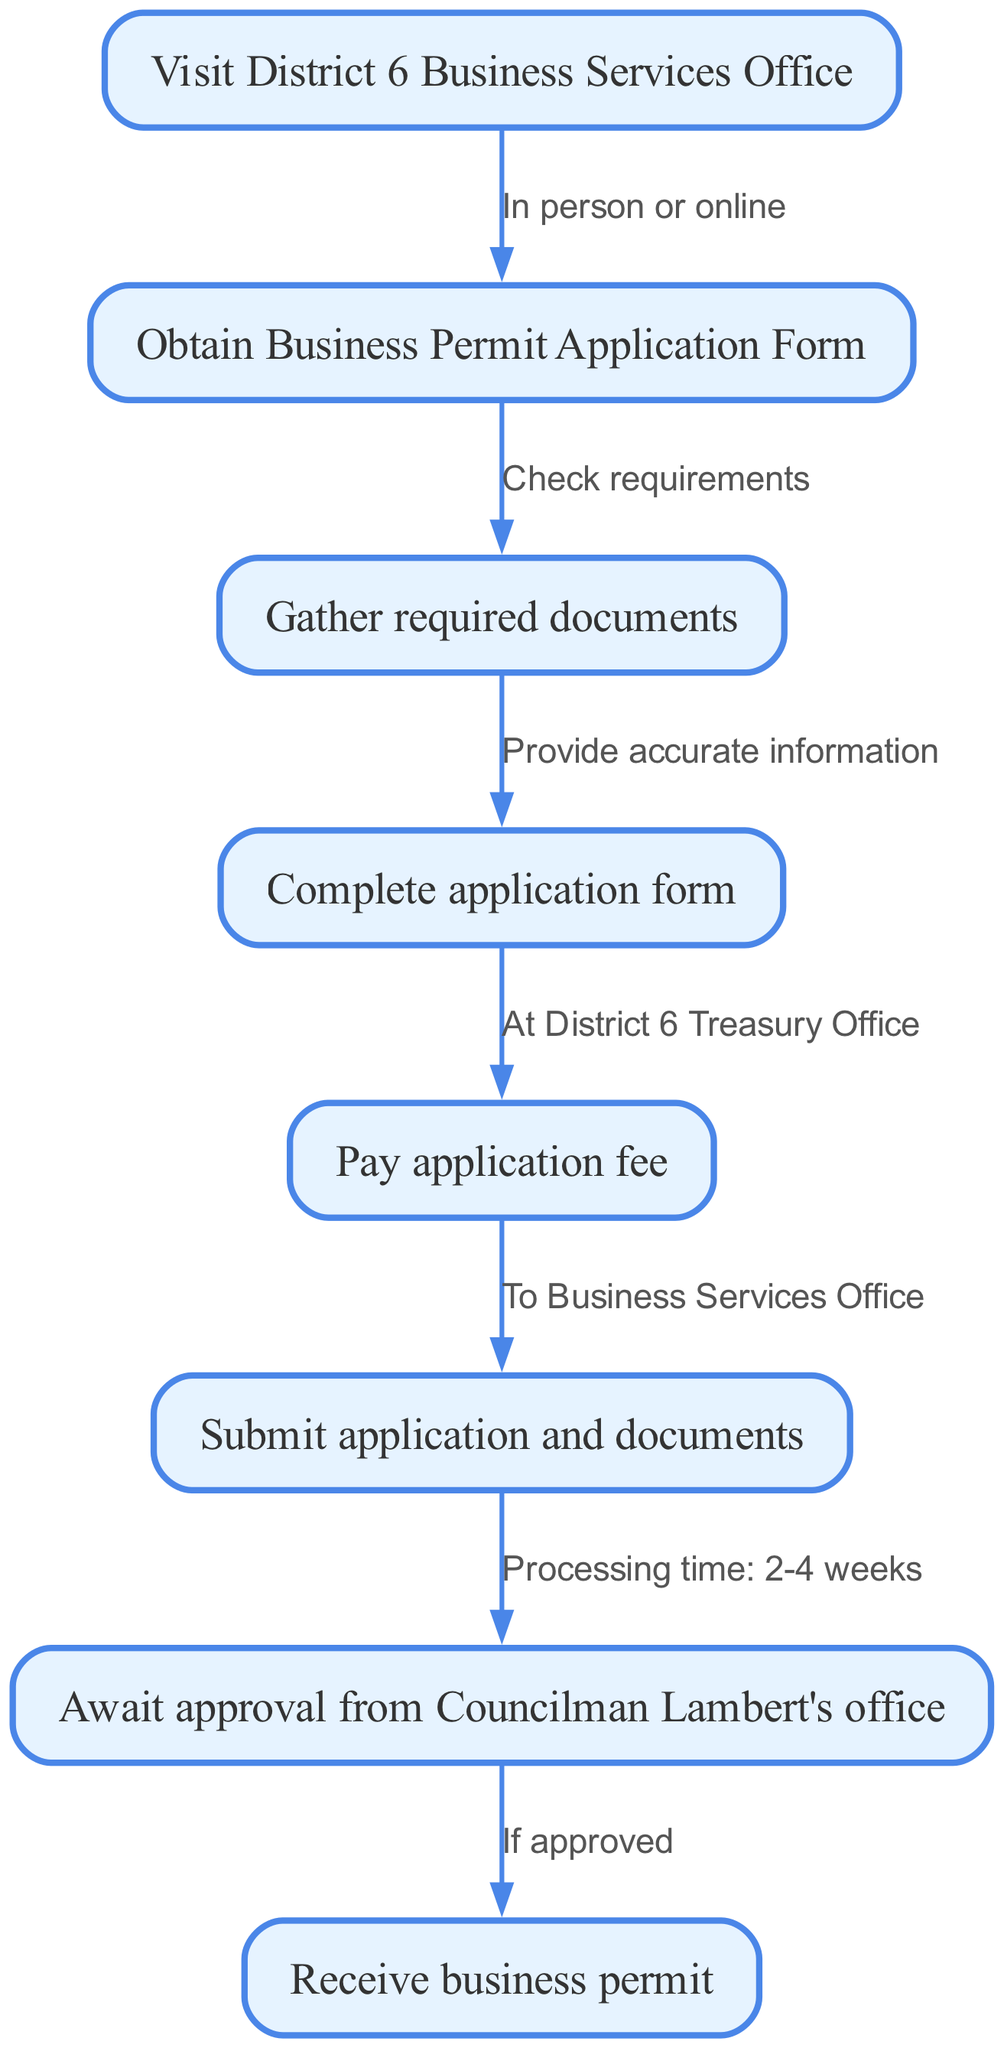What’s the first step in applying for a local business permit? The first step is to visit the District 6 Business Services Office, as indicated by the first node in the diagram.
Answer: Visit District 6 Business Services Office What document do you need to obtain after visiting the office? After visiting the District 6 Business Services Office, you need to obtain the Business Permit Application Form, which is clearly stated in the diagram.
Answer: Obtain Business Permit Application Form How many total steps are in the application process? The diagram shows a total of eight nodes, which correspond to the steps in the application process.
Answer: Eight What do you need to check after obtaining the application form? You need to check the requirements after obtaining the Business Permit Application Form, as shown by the edge connecting these two nodes.
Answer: Check requirements What should you do before paying the application fee? Before paying the application fee, you must complete the application form, which is indicated in the flow from the application step to the payment step.
Answer: Complete application form What is the processing time for the application after submission? The diagram indicates that the processing time from submission to awaiting approval is 2-4 weeks, as detailed in the edge leading to that step.
Answer: 2-4 weeks What is the last step in the application process? The last step in the application process is receiving the business permit, as stated in the final node of the diagram.
Answer: Receive business permit If the application is not approved, what should you do? The diagram implies that if the application is not approved, there are no clear follow-up steps mentioned, as the flow ends at "Await approval from Councilman Lambert's office" leading to "Receive business permit." Thus, further information would be needed.
Answer: N/A 